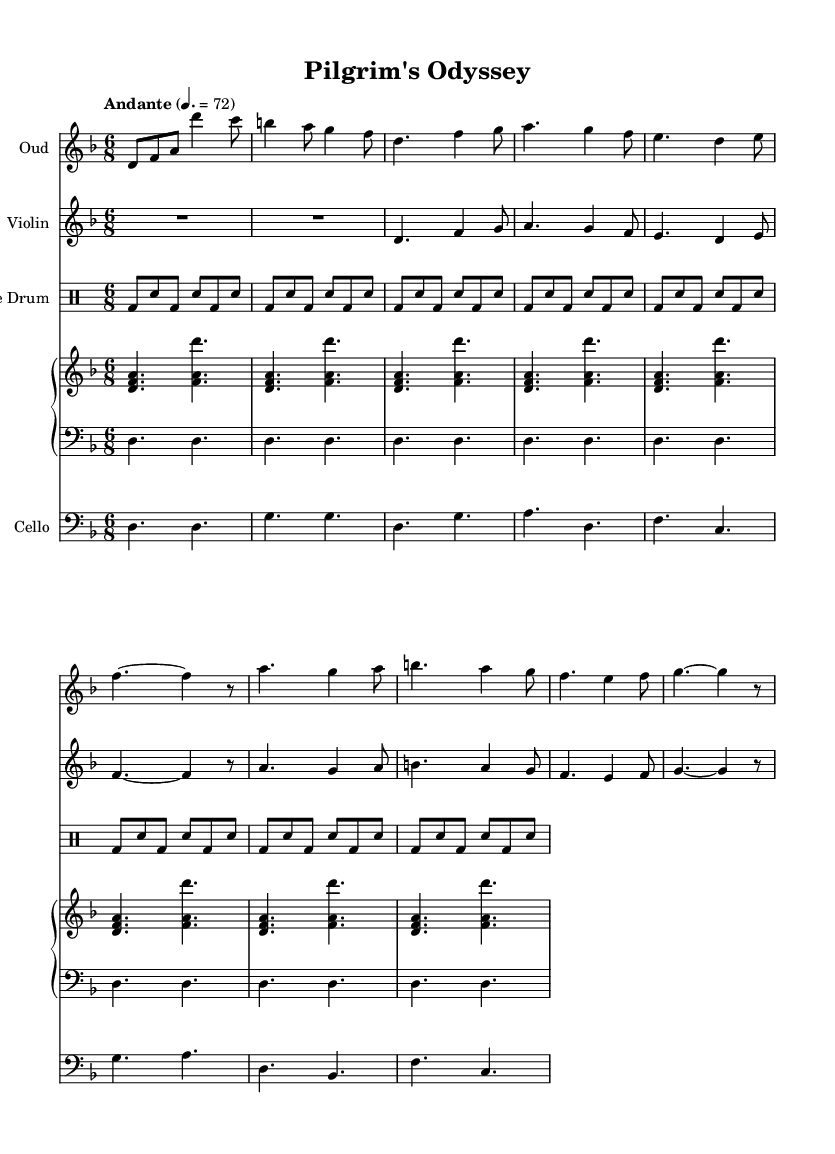What is the key signature of this music? The key signature is D minor, which has one flat (B flat). This can be determined by looking at the key signature symbol at the beginning of the staff.
Answer: D minor What is the time signature of this music? The time signature is 6/8, indicated at the beginning of the score next to the key signature. This shows that there are six eighth-note beats per measure.
Answer: 6/8 What is the tempo marking given in the sheet music? The tempo marking is "Andante," which indicates a moderate pace. This marking is located at the beginning, right after the time signature.
Answer: Andante How many measures are in the oud part? The oud part consists of 16 measures, which can be counted by looking at the end of each measure, indicated by the vertical lines.
Answer: 16 Which instruments feature predominantly in this fusion piece? The predominant instruments in this fusion piece are the oud, violin, frame drum, piano, and cello. This can be observed by looking at the different staves labeled for each instrument at the start of the score.
Answer: Oud, Violin, Frame Drum, Piano, Cello What rhythmic pattern is used in the frame drum part? The frame drum part uses a consistent pattern of bass and snare hits (bd and sn), with a repetitive cycle throughout, which we can see in the drummode indicating repeated eighth notes.
Answer: Bass and snare pattern What type of harmony is primarily used in the piano part? The piano part primarily uses triads based on the notes D, F, and A, which denote a D minor harmony, as evidenced by the stacked notes in the right-hand staff throughout the piece.
Answer: D minor harmony 